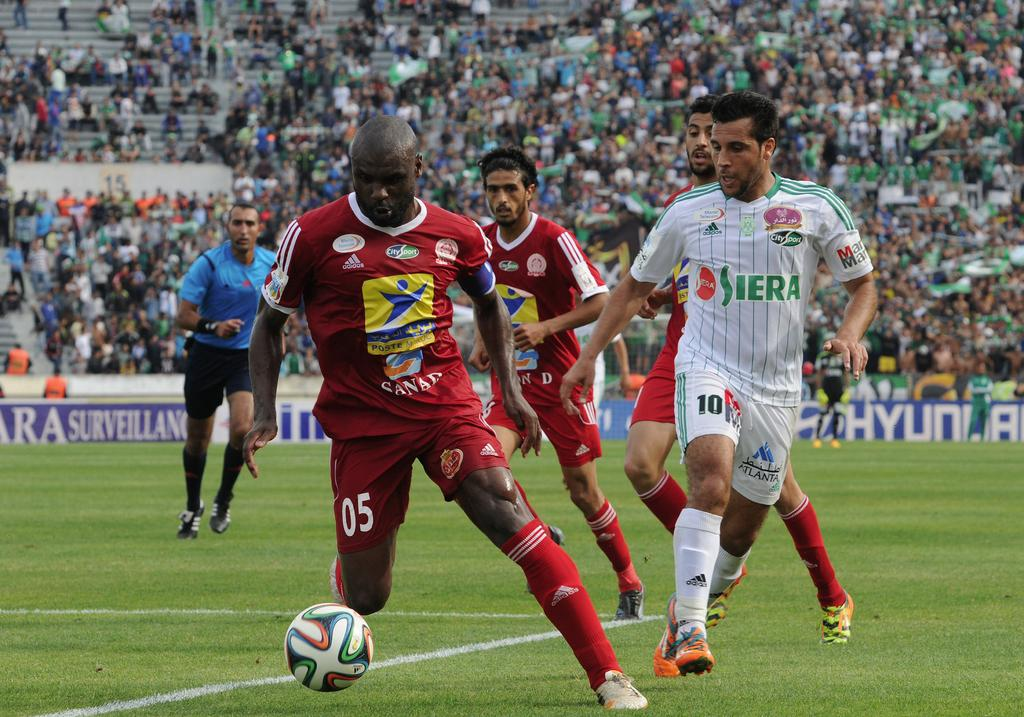<image>
Describe the image concisely. A soccer game is underway at a stadium sponsored by Hyundai. 